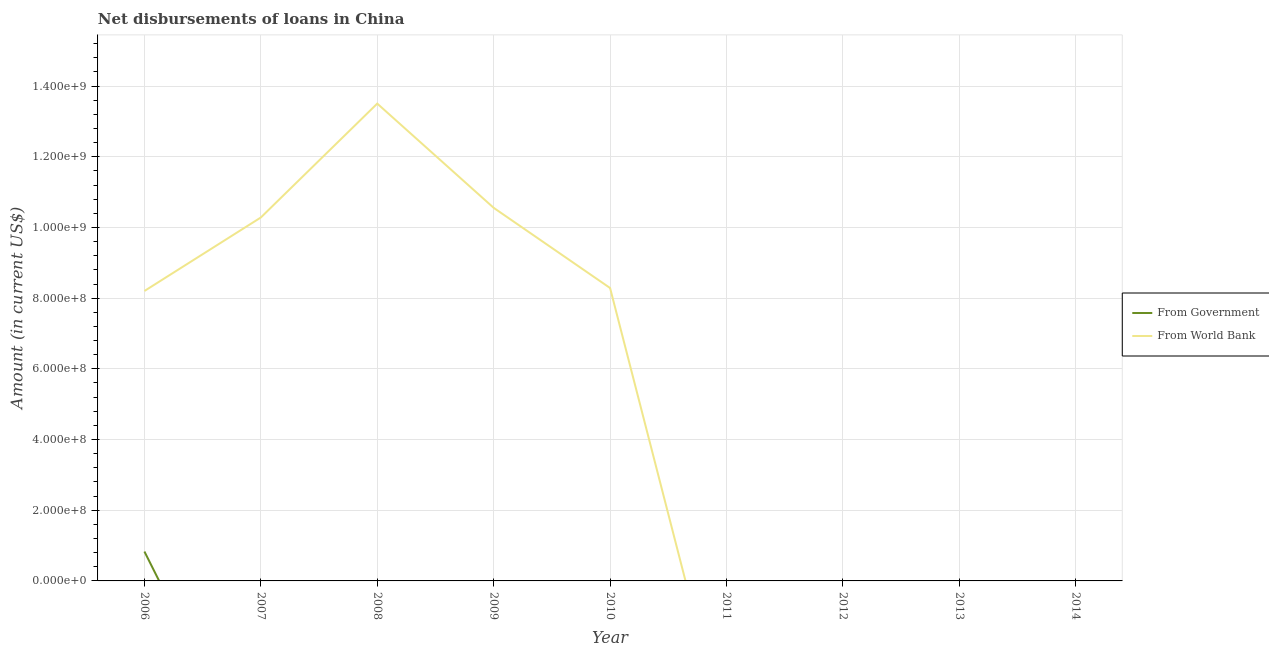Does the line corresponding to net disbursements of loan from world bank intersect with the line corresponding to net disbursements of loan from government?
Offer a very short reply. No. Is the number of lines equal to the number of legend labels?
Make the answer very short. No. Across all years, what is the maximum net disbursements of loan from government?
Offer a very short reply. 8.31e+07. In which year was the net disbursements of loan from world bank maximum?
Your answer should be compact. 2008. What is the total net disbursements of loan from government in the graph?
Ensure brevity in your answer.  8.31e+07. What is the difference between the net disbursements of loan from world bank in 2006 and that in 2010?
Ensure brevity in your answer.  -8.43e+06. What is the average net disbursements of loan from world bank per year?
Your response must be concise. 5.65e+08. In the year 2006, what is the difference between the net disbursements of loan from world bank and net disbursements of loan from government?
Your answer should be compact. 7.37e+08. What is the difference between the highest and the second highest net disbursements of loan from world bank?
Ensure brevity in your answer.  2.95e+08. What is the difference between the highest and the lowest net disbursements of loan from world bank?
Ensure brevity in your answer.  1.35e+09. In how many years, is the net disbursements of loan from world bank greater than the average net disbursements of loan from world bank taken over all years?
Offer a terse response. 5. Is the net disbursements of loan from government strictly greater than the net disbursements of loan from world bank over the years?
Your answer should be very brief. No. How many years are there in the graph?
Ensure brevity in your answer.  9. What is the difference between two consecutive major ticks on the Y-axis?
Your answer should be compact. 2.00e+08. Are the values on the major ticks of Y-axis written in scientific E-notation?
Provide a succinct answer. Yes. Does the graph contain any zero values?
Offer a very short reply. Yes. How many legend labels are there?
Ensure brevity in your answer.  2. How are the legend labels stacked?
Provide a succinct answer. Vertical. What is the title of the graph?
Your answer should be compact. Net disbursements of loans in China. What is the label or title of the Y-axis?
Offer a very short reply. Amount (in current US$). What is the Amount (in current US$) in From Government in 2006?
Your answer should be compact. 8.31e+07. What is the Amount (in current US$) in From World Bank in 2006?
Provide a succinct answer. 8.20e+08. What is the Amount (in current US$) of From Government in 2007?
Your response must be concise. 0. What is the Amount (in current US$) of From World Bank in 2007?
Keep it short and to the point. 1.03e+09. What is the Amount (in current US$) in From Government in 2008?
Your answer should be compact. 0. What is the Amount (in current US$) in From World Bank in 2008?
Keep it short and to the point. 1.35e+09. What is the Amount (in current US$) in From Government in 2009?
Offer a very short reply. 0. What is the Amount (in current US$) of From World Bank in 2009?
Your answer should be compact. 1.06e+09. What is the Amount (in current US$) in From World Bank in 2010?
Provide a succinct answer. 8.29e+08. What is the Amount (in current US$) of From World Bank in 2011?
Make the answer very short. 0. What is the Amount (in current US$) in From Government in 2012?
Ensure brevity in your answer.  0. What is the Amount (in current US$) in From World Bank in 2012?
Offer a terse response. 0. What is the Amount (in current US$) in From Government in 2013?
Your answer should be compact. 0. What is the Amount (in current US$) in From World Bank in 2013?
Keep it short and to the point. 0. What is the Amount (in current US$) of From World Bank in 2014?
Provide a succinct answer. 0. Across all years, what is the maximum Amount (in current US$) in From Government?
Provide a succinct answer. 8.31e+07. Across all years, what is the maximum Amount (in current US$) in From World Bank?
Ensure brevity in your answer.  1.35e+09. What is the total Amount (in current US$) in From Government in the graph?
Keep it short and to the point. 8.31e+07. What is the total Amount (in current US$) of From World Bank in the graph?
Provide a succinct answer. 5.08e+09. What is the difference between the Amount (in current US$) in From World Bank in 2006 and that in 2007?
Keep it short and to the point. -2.08e+08. What is the difference between the Amount (in current US$) in From World Bank in 2006 and that in 2008?
Give a very brief answer. -5.30e+08. What is the difference between the Amount (in current US$) of From World Bank in 2006 and that in 2009?
Your response must be concise. -2.35e+08. What is the difference between the Amount (in current US$) of From World Bank in 2006 and that in 2010?
Offer a terse response. -8.43e+06. What is the difference between the Amount (in current US$) in From World Bank in 2007 and that in 2008?
Your answer should be compact. -3.22e+08. What is the difference between the Amount (in current US$) of From World Bank in 2007 and that in 2009?
Provide a succinct answer. -2.74e+07. What is the difference between the Amount (in current US$) in From World Bank in 2007 and that in 2010?
Offer a terse response. 2.00e+08. What is the difference between the Amount (in current US$) in From World Bank in 2008 and that in 2009?
Make the answer very short. 2.95e+08. What is the difference between the Amount (in current US$) of From World Bank in 2008 and that in 2010?
Provide a short and direct response. 5.22e+08. What is the difference between the Amount (in current US$) of From World Bank in 2009 and that in 2010?
Offer a very short reply. 2.27e+08. What is the difference between the Amount (in current US$) in From Government in 2006 and the Amount (in current US$) in From World Bank in 2007?
Give a very brief answer. -9.45e+08. What is the difference between the Amount (in current US$) in From Government in 2006 and the Amount (in current US$) in From World Bank in 2008?
Your response must be concise. -1.27e+09. What is the difference between the Amount (in current US$) of From Government in 2006 and the Amount (in current US$) of From World Bank in 2009?
Keep it short and to the point. -9.72e+08. What is the difference between the Amount (in current US$) of From Government in 2006 and the Amount (in current US$) of From World Bank in 2010?
Provide a succinct answer. -7.46e+08. What is the average Amount (in current US$) of From Government per year?
Keep it short and to the point. 9.24e+06. What is the average Amount (in current US$) of From World Bank per year?
Your answer should be compact. 5.65e+08. In the year 2006, what is the difference between the Amount (in current US$) of From Government and Amount (in current US$) of From World Bank?
Provide a succinct answer. -7.37e+08. What is the ratio of the Amount (in current US$) in From World Bank in 2006 to that in 2007?
Offer a terse response. 0.8. What is the ratio of the Amount (in current US$) of From World Bank in 2006 to that in 2008?
Offer a terse response. 0.61. What is the ratio of the Amount (in current US$) in From World Bank in 2006 to that in 2009?
Offer a terse response. 0.78. What is the ratio of the Amount (in current US$) in From World Bank in 2006 to that in 2010?
Provide a succinct answer. 0.99. What is the ratio of the Amount (in current US$) in From World Bank in 2007 to that in 2008?
Offer a very short reply. 0.76. What is the ratio of the Amount (in current US$) in From World Bank in 2007 to that in 2009?
Make the answer very short. 0.97. What is the ratio of the Amount (in current US$) of From World Bank in 2007 to that in 2010?
Offer a terse response. 1.24. What is the ratio of the Amount (in current US$) of From World Bank in 2008 to that in 2009?
Keep it short and to the point. 1.28. What is the ratio of the Amount (in current US$) in From World Bank in 2008 to that in 2010?
Keep it short and to the point. 1.63. What is the ratio of the Amount (in current US$) in From World Bank in 2009 to that in 2010?
Your answer should be compact. 1.27. What is the difference between the highest and the second highest Amount (in current US$) in From World Bank?
Your response must be concise. 2.95e+08. What is the difference between the highest and the lowest Amount (in current US$) in From Government?
Provide a succinct answer. 8.31e+07. What is the difference between the highest and the lowest Amount (in current US$) in From World Bank?
Make the answer very short. 1.35e+09. 